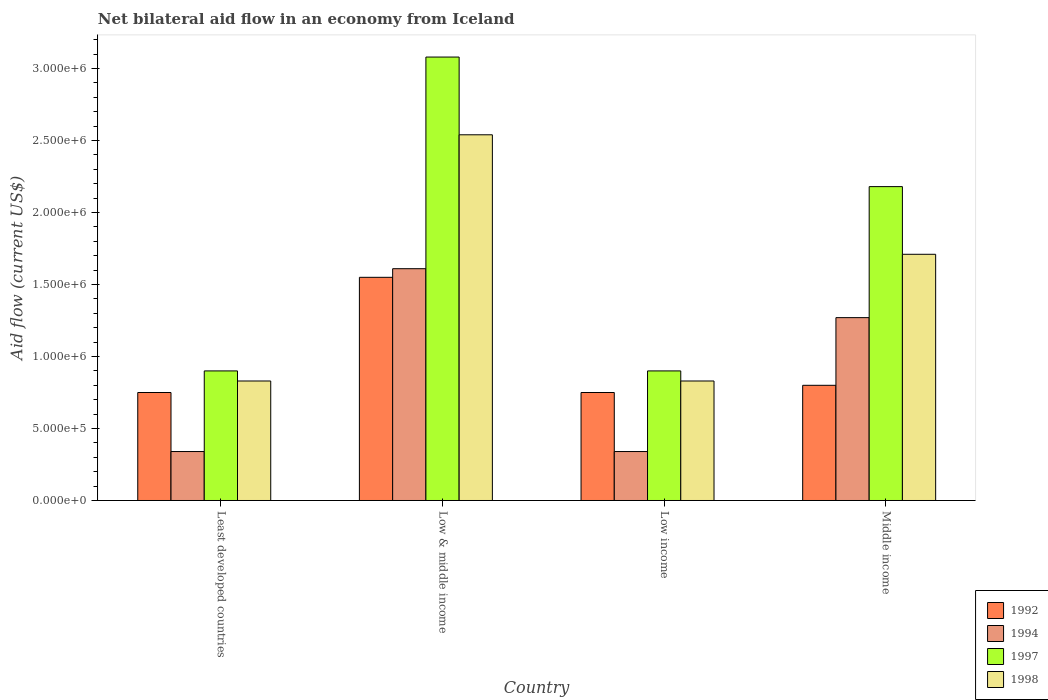How many bars are there on the 1st tick from the right?
Give a very brief answer. 4. In how many cases, is the number of bars for a given country not equal to the number of legend labels?
Ensure brevity in your answer.  0. What is the net bilateral aid flow in 1994 in Middle income?
Make the answer very short. 1.27e+06. Across all countries, what is the maximum net bilateral aid flow in 1998?
Your answer should be very brief. 2.54e+06. In which country was the net bilateral aid flow in 1997 minimum?
Provide a succinct answer. Least developed countries. What is the total net bilateral aid flow in 1992 in the graph?
Offer a very short reply. 3.85e+06. What is the difference between the net bilateral aid flow in 1992 in Least developed countries and that in Low income?
Your answer should be very brief. 0. What is the difference between the net bilateral aid flow in 1994 in Middle income and the net bilateral aid flow in 1997 in Low & middle income?
Your response must be concise. -1.81e+06. What is the average net bilateral aid flow in 1997 per country?
Provide a short and direct response. 1.76e+06. What is the difference between the net bilateral aid flow of/in 1994 and net bilateral aid flow of/in 1992 in Low & middle income?
Provide a succinct answer. 6.00e+04. In how many countries, is the net bilateral aid flow in 1998 greater than 700000 US$?
Your response must be concise. 4. What is the ratio of the net bilateral aid flow in 1998 in Least developed countries to that in Low & middle income?
Your answer should be very brief. 0.33. Is the difference between the net bilateral aid flow in 1994 in Least developed countries and Low & middle income greater than the difference between the net bilateral aid flow in 1992 in Least developed countries and Low & middle income?
Your response must be concise. No. What is the difference between the highest and the second highest net bilateral aid flow in 1992?
Make the answer very short. 7.50e+05. What is the difference between the highest and the lowest net bilateral aid flow in 1994?
Provide a short and direct response. 1.27e+06. Is the sum of the net bilateral aid flow in 1992 in Low income and Middle income greater than the maximum net bilateral aid flow in 1997 across all countries?
Offer a terse response. No. How many bars are there?
Provide a short and direct response. 16. How many countries are there in the graph?
Your answer should be compact. 4. Are the values on the major ticks of Y-axis written in scientific E-notation?
Offer a very short reply. Yes. Does the graph contain any zero values?
Make the answer very short. No. How many legend labels are there?
Your answer should be very brief. 4. What is the title of the graph?
Your answer should be very brief. Net bilateral aid flow in an economy from Iceland. What is the label or title of the Y-axis?
Provide a short and direct response. Aid flow (current US$). What is the Aid flow (current US$) of 1992 in Least developed countries?
Offer a very short reply. 7.50e+05. What is the Aid flow (current US$) of 1998 in Least developed countries?
Offer a terse response. 8.30e+05. What is the Aid flow (current US$) in 1992 in Low & middle income?
Keep it short and to the point. 1.55e+06. What is the Aid flow (current US$) of 1994 in Low & middle income?
Provide a succinct answer. 1.61e+06. What is the Aid flow (current US$) in 1997 in Low & middle income?
Your answer should be compact. 3.08e+06. What is the Aid flow (current US$) in 1998 in Low & middle income?
Your answer should be compact. 2.54e+06. What is the Aid flow (current US$) of 1992 in Low income?
Offer a very short reply. 7.50e+05. What is the Aid flow (current US$) in 1994 in Low income?
Offer a terse response. 3.40e+05. What is the Aid flow (current US$) in 1998 in Low income?
Your response must be concise. 8.30e+05. What is the Aid flow (current US$) of 1992 in Middle income?
Ensure brevity in your answer.  8.00e+05. What is the Aid flow (current US$) in 1994 in Middle income?
Ensure brevity in your answer.  1.27e+06. What is the Aid flow (current US$) in 1997 in Middle income?
Provide a short and direct response. 2.18e+06. What is the Aid flow (current US$) in 1998 in Middle income?
Offer a terse response. 1.71e+06. Across all countries, what is the maximum Aid flow (current US$) in 1992?
Your response must be concise. 1.55e+06. Across all countries, what is the maximum Aid flow (current US$) in 1994?
Your answer should be very brief. 1.61e+06. Across all countries, what is the maximum Aid flow (current US$) of 1997?
Provide a succinct answer. 3.08e+06. Across all countries, what is the maximum Aid flow (current US$) in 1998?
Your answer should be compact. 2.54e+06. Across all countries, what is the minimum Aid flow (current US$) in 1992?
Your answer should be compact. 7.50e+05. Across all countries, what is the minimum Aid flow (current US$) in 1997?
Offer a terse response. 9.00e+05. Across all countries, what is the minimum Aid flow (current US$) of 1998?
Ensure brevity in your answer.  8.30e+05. What is the total Aid flow (current US$) in 1992 in the graph?
Offer a very short reply. 3.85e+06. What is the total Aid flow (current US$) of 1994 in the graph?
Make the answer very short. 3.56e+06. What is the total Aid flow (current US$) in 1997 in the graph?
Keep it short and to the point. 7.06e+06. What is the total Aid flow (current US$) of 1998 in the graph?
Give a very brief answer. 5.91e+06. What is the difference between the Aid flow (current US$) in 1992 in Least developed countries and that in Low & middle income?
Provide a short and direct response. -8.00e+05. What is the difference between the Aid flow (current US$) in 1994 in Least developed countries and that in Low & middle income?
Ensure brevity in your answer.  -1.27e+06. What is the difference between the Aid flow (current US$) of 1997 in Least developed countries and that in Low & middle income?
Your answer should be compact. -2.18e+06. What is the difference between the Aid flow (current US$) in 1998 in Least developed countries and that in Low & middle income?
Your response must be concise. -1.71e+06. What is the difference between the Aid flow (current US$) in 1992 in Least developed countries and that in Low income?
Provide a succinct answer. 0. What is the difference between the Aid flow (current US$) of 1994 in Least developed countries and that in Low income?
Offer a terse response. 0. What is the difference between the Aid flow (current US$) of 1997 in Least developed countries and that in Low income?
Give a very brief answer. 0. What is the difference between the Aid flow (current US$) of 1998 in Least developed countries and that in Low income?
Keep it short and to the point. 0. What is the difference between the Aid flow (current US$) of 1992 in Least developed countries and that in Middle income?
Your answer should be compact. -5.00e+04. What is the difference between the Aid flow (current US$) of 1994 in Least developed countries and that in Middle income?
Keep it short and to the point. -9.30e+05. What is the difference between the Aid flow (current US$) of 1997 in Least developed countries and that in Middle income?
Ensure brevity in your answer.  -1.28e+06. What is the difference between the Aid flow (current US$) of 1998 in Least developed countries and that in Middle income?
Ensure brevity in your answer.  -8.80e+05. What is the difference between the Aid flow (current US$) of 1992 in Low & middle income and that in Low income?
Give a very brief answer. 8.00e+05. What is the difference between the Aid flow (current US$) in 1994 in Low & middle income and that in Low income?
Provide a succinct answer. 1.27e+06. What is the difference between the Aid flow (current US$) in 1997 in Low & middle income and that in Low income?
Your answer should be very brief. 2.18e+06. What is the difference between the Aid flow (current US$) of 1998 in Low & middle income and that in Low income?
Provide a short and direct response. 1.71e+06. What is the difference between the Aid flow (current US$) of 1992 in Low & middle income and that in Middle income?
Provide a short and direct response. 7.50e+05. What is the difference between the Aid flow (current US$) in 1994 in Low & middle income and that in Middle income?
Your response must be concise. 3.40e+05. What is the difference between the Aid flow (current US$) in 1997 in Low & middle income and that in Middle income?
Give a very brief answer. 9.00e+05. What is the difference between the Aid flow (current US$) of 1998 in Low & middle income and that in Middle income?
Your response must be concise. 8.30e+05. What is the difference between the Aid flow (current US$) in 1994 in Low income and that in Middle income?
Keep it short and to the point. -9.30e+05. What is the difference between the Aid flow (current US$) of 1997 in Low income and that in Middle income?
Keep it short and to the point. -1.28e+06. What is the difference between the Aid flow (current US$) of 1998 in Low income and that in Middle income?
Your response must be concise. -8.80e+05. What is the difference between the Aid flow (current US$) of 1992 in Least developed countries and the Aid flow (current US$) of 1994 in Low & middle income?
Provide a succinct answer. -8.60e+05. What is the difference between the Aid flow (current US$) of 1992 in Least developed countries and the Aid flow (current US$) of 1997 in Low & middle income?
Make the answer very short. -2.33e+06. What is the difference between the Aid flow (current US$) of 1992 in Least developed countries and the Aid flow (current US$) of 1998 in Low & middle income?
Give a very brief answer. -1.79e+06. What is the difference between the Aid flow (current US$) of 1994 in Least developed countries and the Aid flow (current US$) of 1997 in Low & middle income?
Keep it short and to the point. -2.74e+06. What is the difference between the Aid flow (current US$) in 1994 in Least developed countries and the Aid flow (current US$) in 1998 in Low & middle income?
Offer a terse response. -2.20e+06. What is the difference between the Aid flow (current US$) in 1997 in Least developed countries and the Aid flow (current US$) in 1998 in Low & middle income?
Provide a succinct answer. -1.64e+06. What is the difference between the Aid flow (current US$) of 1992 in Least developed countries and the Aid flow (current US$) of 1994 in Low income?
Offer a very short reply. 4.10e+05. What is the difference between the Aid flow (current US$) of 1992 in Least developed countries and the Aid flow (current US$) of 1997 in Low income?
Your answer should be compact. -1.50e+05. What is the difference between the Aid flow (current US$) in 1992 in Least developed countries and the Aid flow (current US$) in 1998 in Low income?
Provide a short and direct response. -8.00e+04. What is the difference between the Aid flow (current US$) of 1994 in Least developed countries and the Aid flow (current US$) of 1997 in Low income?
Provide a succinct answer. -5.60e+05. What is the difference between the Aid flow (current US$) in 1994 in Least developed countries and the Aid flow (current US$) in 1998 in Low income?
Your answer should be very brief. -4.90e+05. What is the difference between the Aid flow (current US$) in 1997 in Least developed countries and the Aid flow (current US$) in 1998 in Low income?
Keep it short and to the point. 7.00e+04. What is the difference between the Aid flow (current US$) of 1992 in Least developed countries and the Aid flow (current US$) of 1994 in Middle income?
Your answer should be compact. -5.20e+05. What is the difference between the Aid flow (current US$) in 1992 in Least developed countries and the Aid flow (current US$) in 1997 in Middle income?
Provide a succinct answer. -1.43e+06. What is the difference between the Aid flow (current US$) in 1992 in Least developed countries and the Aid flow (current US$) in 1998 in Middle income?
Make the answer very short. -9.60e+05. What is the difference between the Aid flow (current US$) of 1994 in Least developed countries and the Aid flow (current US$) of 1997 in Middle income?
Offer a very short reply. -1.84e+06. What is the difference between the Aid flow (current US$) of 1994 in Least developed countries and the Aid flow (current US$) of 1998 in Middle income?
Your response must be concise. -1.37e+06. What is the difference between the Aid flow (current US$) in 1997 in Least developed countries and the Aid flow (current US$) in 1998 in Middle income?
Give a very brief answer. -8.10e+05. What is the difference between the Aid flow (current US$) in 1992 in Low & middle income and the Aid flow (current US$) in 1994 in Low income?
Provide a short and direct response. 1.21e+06. What is the difference between the Aid flow (current US$) of 1992 in Low & middle income and the Aid flow (current US$) of 1997 in Low income?
Your response must be concise. 6.50e+05. What is the difference between the Aid flow (current US$) in 1992 in Low & middle income and the Aid flow (current US$) in 1998 in Low income?
Provide a short and direct response. 7.20e+05. What is the difference between the Aid flow (current US$) in 1994 in Low & middle income and the Aid flow (current US$) in 1997 in Low income?
Ensure brevity in your answer.  7.10e+05. What is the difference between the Aid flow (current US$) in 1994 in Low & middle income and the Aid flow (current US$) in 1998 in Low income?
Your response must be concise. 7.80e+05. What is the difference between the Aid flow (current US$) in 1997 in Low & middle income and the Aid flow (current US$) in 1998 in Low income?
Provide a succinct answer. 2.25e+06. What is the difference between the Aid flow (current US$) of 1992 in Low & middle income and the Aid flow (current US$) of 1997 in Middle income?
Ensure brevity in your answer.  -6.30e+05. What is the difference between the Aid flow (current US$) in 1994 in Low & middle income and the Aid flow (current US$) in 1997 in Middle income?
Offer a terse response. -5.70e+05. What is the difference between the Aid flow (current US$) of 1994 in Low & middle income and the Aid flow (current US$) of 1998 in Middle income?
Your answer should be compact. -1.00e+05. What is the difference between the Aid flow (current US$) in 1997 in Low & middle income and the Aid flow (current US$) in 1998 in Middle income?
Keep it short and to the point. 1.37e+06. What is the difference between the Aid flow (current US$) of 1992 in Low income and the Aid flow (current US$) of 1994 in Middle income?
Keep it short and to the point. -5.20e+05. What is the difference between the Aid flow (current US$) in 1992 in Low income and the Aid flow (current US$) in 1997 in Middle income?
Your response must be concise. -1.43e+06. What is the difference between the Aid flow (current US$) of 1992 in Low income and the Aid flow (current US$) of 1998 in Middle income?
Ensure brevity in your answer.  -9.60e+05. What is the difference between the Aid flow (current US$) of 1994 in Low income and the Aid flow (current US$) of 1997 in Middle income?
Your response must be concise. -1.84e+06. What is the difference between the Aid flow (current US$) in 1994 in Low income and the Aid flow (current US$) in 1998 in Middle income?
Your answer should be compact. -1.37e+06. What is the difference between the Aid flow (current US$) in 1997 in Low income and the Aid flow (current US$) in 1998 in Middle income?
Keep it short and to the point. -8.10e+05. What is the average Aid flow (current US$) in 1992 per country?
Provide a succinct answer. 9.62e+05. What is the average Aid flow (current US$) of 1994 per country?
Your response must be concise. 8.90e+05. What is the average Aid flow (current US$) in 1997 per country?
Keep it short and to the point. 1.76e+06. What is the average Aid flow (current US$) of 1998 per country?
Give a very brief answer. 1.48e+06. What is the difference between the Aid flow (current US$) in 1992 and Aid flow (current US$) in 1994 in Least developed countries?
Keep it short and to the point. 4.10e+05. What is the difference between the Aid flow (current US$) of 1992 and Aid flow (current US$) of 1998 in Least developed countries?
Provide a succinct answer. -8.00e+04. What is the difference between the Aid flow (current US$) of 1994 and Aid flow (current US$) of 1997 in Least developed countries?
Your response must be concise. -5.60e+05. What is the difference between the Aid flow (current US$) in 1994 and Aid flow (current US$) in 1998 in Least developed countries?
Give a very brief answer. -4.90e+05. What is the difference between the Aid flow (current US$) of 1997 and Aid flow (current US$) of 1998 in Least developed countries?
Keep it short and to the point. 7.00e+04. What is the difference between the Aid flow (current US$) of 1992 and Aid flow (current US$) of 1994 in Low & middle income?
Give a very brief answer. -6.00e+04. What is the difference between the Aid flow (current US$) in 1992 and Aid flow (current US$) in 1997 in Low & middle income?
Your response must be concise. -1.53e+06. What is the difference between the Aid flow (current US$) of 1992 and Aid flow (current US$) of 1998 in Low & middle income?
Give a very brief answer. -9.90e+05. What is the difference between the Aid flow (current US$) in 1994 and Aid flow (current US$) in 1997 in Low & middle income?
Your answer should be compact. -1.47e+06. What is the difference between the Aid flow (current US$) of 1994 and Aid flow (current US$) of 1998 in Low & middle income?
Keep it short and to the point. -9.30e+05. What is the difference between the Aid flow (current US$) of 1997 and Aid flow (current US$) of 1998 in Low & middle income?
Offer a very short reply. 5.40e+05. What is the difference between the Aid flow (current US$) of 1994 and Aid flow (current US$) of 1997 in Low income?
Your response must be concise. -5.60e+05. What is the difference between the Aid flow (current US$) of 1994 and Aid flow (current US$) of 1998 in Low income?
Offer a terse response. -4.90e+05. What is the difference between the Aid flow (current US$) in 1992 and Aid flow (current US$) in 1994 in Middle income?
Provide a short and direct response. -4.70e+05. What is the difference between the Aid flow (current US$) of 1992 and Aid flow (current US$) of 1997 in Middle income?
Provide a short and direct response. -1.38e+06. What is the difference between the Aid flow (current US$) in 1992 and Aid flow (current US$) in 1998 in Middle income?
Your answer should be compact. -9.10e+05. What is the difference between the Aid flow (current US$) in 1994 and Aid flow (current US$) in 1997 in Middle income?
Keep it short and to the point. -9.10e+05. What is the difference between the Aid flow (current US$) in 1994 and Aid flow (current US$) in 1998 in Middle income?
Keep it short and to the point. -4.40e+05. What is the ratio of the Aid flow (current US$) in 1992 in Least developed countries to that in Low & middle income?
Provide a short and direct response. 0.48. What is the ratio of the Aid flow (current US$) of 1994 in Least developed countries to that in Low & middle income?
Give a very brief answer. 0.21. What is the ratio of the Aid flow (current US$) in 1997 in Least developed countries to that in Low & middle income?
Your response must be concise. 0.29. What is the ratio of the Aid flow (current US$) of 1998 in Least developed countries to that in Low & middle income?
Keep it short and to the point. 0.33. What is the ratio of the Aid flow (current US$) of 1992 in Least developed countries to that in Low income?
Keep it short and to the point. 1. What is the ratio of the Aid flow (current US$) in 1992 in Least developed countries to that in Middle income?
Make the answer very short. 0.94. What is the ratio of the Aid flow (current US$) of 1994 in Least developed countries to that in Middle income?
Offer a terse response. 0.27. What is the ratio of the Aid flow (current US$) of 1997 in Least developed countries to that in Middle income?
Your response must be concise. 0.41. What is the ratio of the Aid flow (current US$) of 1998 in Least developed countries to that in Middle income?
Make the answer very short. 0.49. What is the ratio of the Aid flow (current US$) of 1992 in Low & middle income to that in Low income?
Offer a terse response. 2.07. What is the ratio of the Aid flow (current US$) in 1994 in Low & middle income to that in Low income?
Provide a short and direct response. 4.74. What is the ratio of the Aid flow (current US$) in 1997 in Low & middle income to that in Low income?
Your answer should be compact. 3.42. What is the ratio of the Aid flow (current US$) in 1998 in Low & middle income to that in Low income?
Make the answer very short. 3.06. What is the ratio of the Aid flow (current US$) in 1992 in Low & middle income to that in Middle income?
Ensure brevity in your answer.  1.94. What is the ratio of the Aid flow (current US$) of 1994 in Low & middle income to that in Middle income?
Your answer should be very brief. 1.27. What is the ratio of the Aid flow (current US$) in 1997 in Low & middle income to that in Middle income?
Your answer should be compact. 1.41. What is the ratio of the Aid flow (current US$) in 1998 in Low & middle income to that in Middle income?
Your answer should be very brief. 1.49. What is the ratio of the Aid flow (current US$) in 1994 in Low income to that in Middle income?
Make the answer very short. 0.27. What is the ratio of the Aid flow (current US$) in 1997 in Low income to that in Middle income?
Offer a terse response. 0.41. What is the ratio of the Aid flow (current US$) in 1998 in Low income to that in Middle income?
Your response must be concise. 0.49. What is the difference between the highest and the second highest Aid flow (current US$) of 1992?
Your answer should be compact. 7.50e+05. What is the difference between the highest and the second highest Aid flow (current US$) in 1994?
Keep it short and to the point. 3.40e+05. What is the difference between the highest and the second highest Aid flow (current US$) in 1997?
Your response must be concise. 9.00e+05. What is the difference between the highest and the second highest Aid flow (current US$) in 1998?
Offer a terse response. 8.30e+05. What is the difference between the highest and the lowest Aid flow (current US$) of 1992?
Keep it short and to the point. 8.00e+05. What is the difference between the highest and the lowest Aid flow (current US$) in 1994?
Offer a terse response. 1.27e+06. What is the difference between the highest and the lowest Aid flow (current US$) of 1997?
Offer a very short reply. 2.18e+06. What is the difference between the highest and the lowest Aid flow (current US$) of 1998?
Make the answer very short. 1.71e+06. 